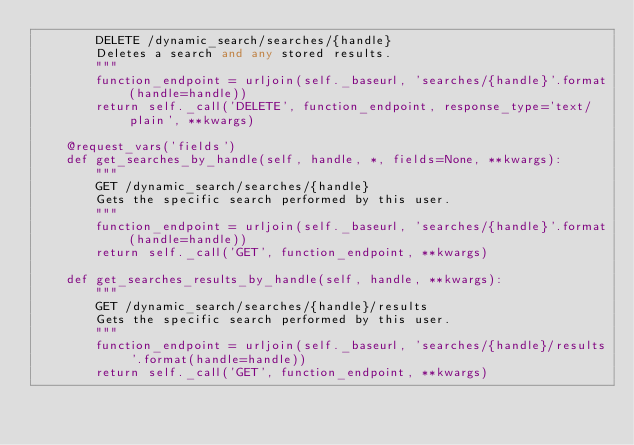Convert code to text. <code><loc_0><loc_0><loc_500><loc_500><_Python_>        DELETE /dynamic_search/searches/{handle}
        Deletes a search and any stored results.
        """
        function_endpoint = urljoin(self._baseurl, 'searches/{handle}'.format(handle=handle))
        return self._call('DELETE', function_endpoint, response_type='text/plain', **kwargs)

    @request_vars('fields')
    def get_searches_by_handle(self, handle, *, fields=None, **kwargs):
        """
        GET /dynamic_search/searches/{handle}
        Gets the specific search performed by this user.
        """
        function_endpoint = urljoin(self._baseurl, 'searches/{handle}'.format(handle=handle))
        return self._call('GET', function_endpoint, **kwargs)

    def get_searches_results_by_handle(self, handle, **kwargs):
        """
        GET /dynamic_search/searches/{handle}/results
        Gets the specific search performed by this user.
        """
        function_endpoint = urljoin(self._baseurl, 'searches/{handle}/results'.format(handle=handle))
        return self._call('GET', function_endpoint, **kwargs)
</code> 